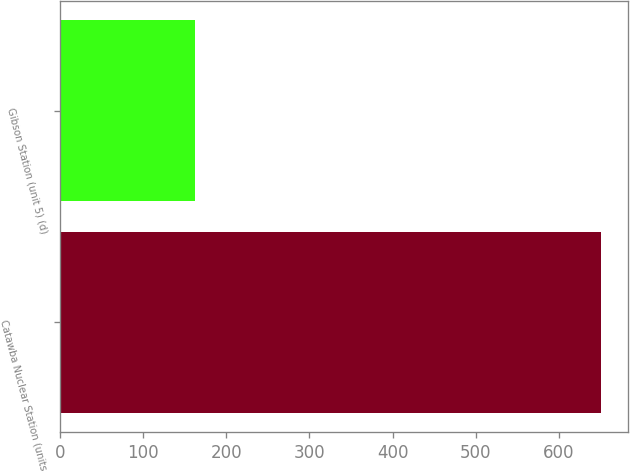Convert chart. <chart><loc_0><loc_0><loc_500><loc_500><bar_chart><fcel>Catawba Nuclear Station (units<fcel>Gibson Station (unit 5) (d)<nl><fcel>651<fcel>162<nl></chart> 